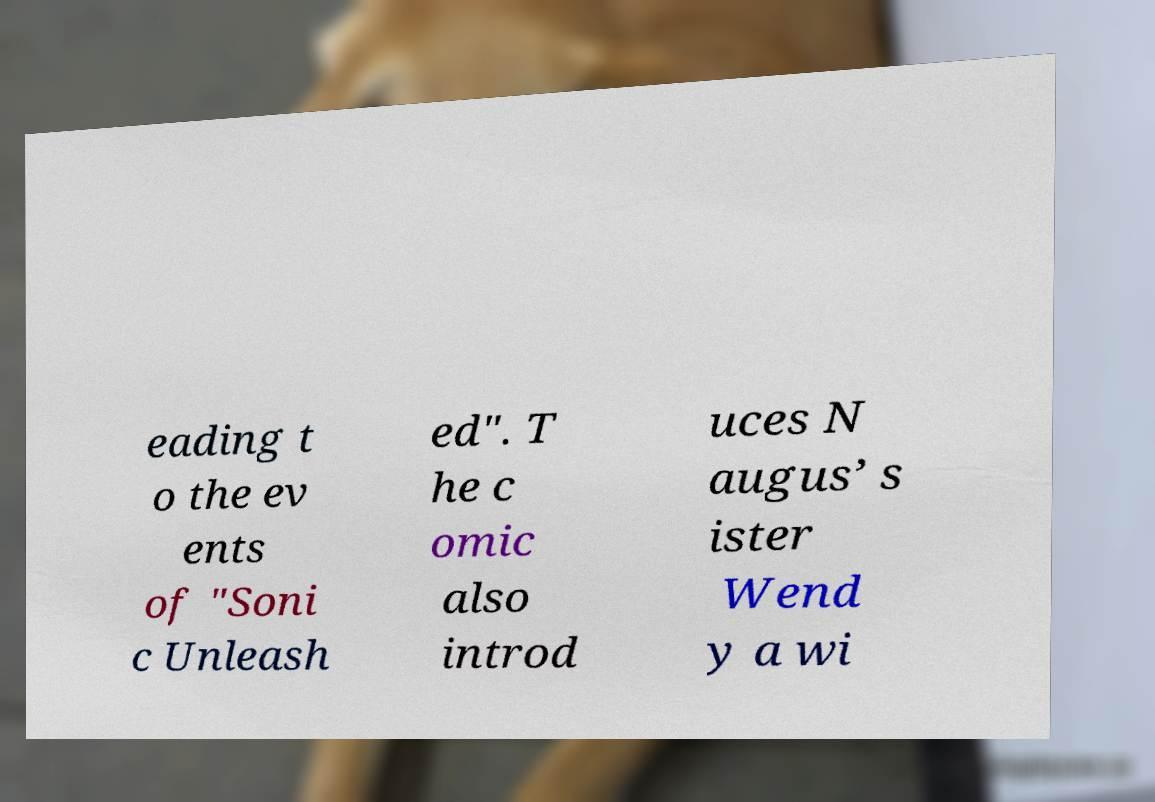For documentation purposes, I need the text within this image transcribed. Could you provide that? eading t o the ev ents of "Soni c Unleash ed". T he c omic also introd uces N augus’ s ister Wend y a wi 